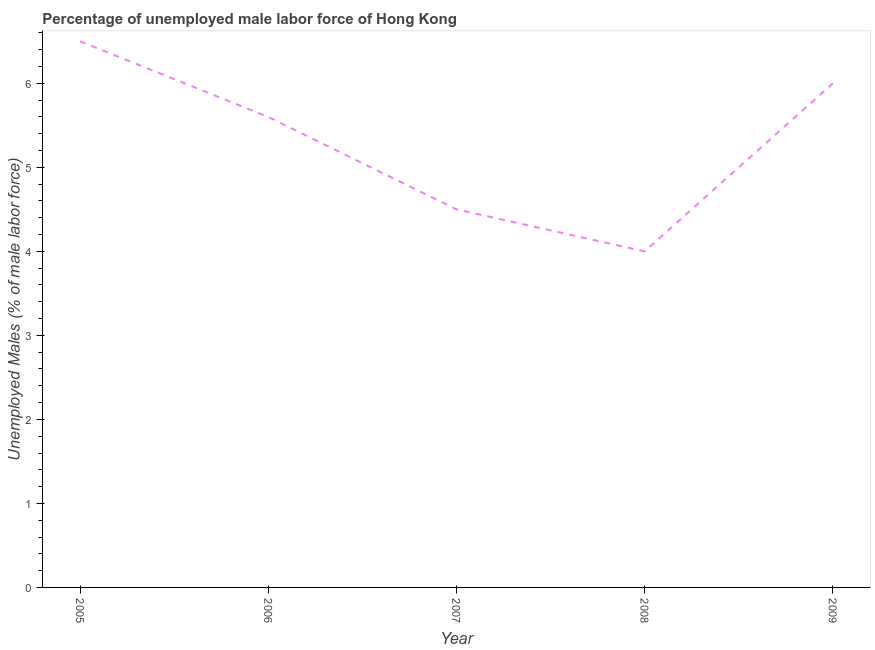What is the total unemployed male labour force in 2006?
Your response must be concise. 5.6. Across all years, what is the maximum total unemployed male labour force?
Keep it short and to the point. 6.5. Across all years, what is the minimum total unemployed male labour force?
Offer a terse response. 4. In which year was the total unemployed male labour force minimum?
Make the answer very short. 2008. What is the sum of the total unemployed male labour force?
Keep it short and to the point. 26.6. What is the difference between the total unemployed male labour force in 2006 and 2007?
Provide a short and direct response. 1.1. What is the average total unemployed male labour force per year?
Your answer should be compact. 5.32. What is the median total unemployed male labour force?
Your response must be concise. 5.6. In how many years, is the total unemployed male labour force greater than 0.4 %?
Provide a succinct answer. 5. Do a majority of the years between 2009 and 2007 (inclusive) have total unemployed male labour force greater than 4.8 %?
Provide a succinct answer. No. What is the ratio of the total unemployed male labour force in 2007 to that in 2008?
Provide a succinct answer. 1.12. Is the total unemployed male labour force in 2006 less than that in 2007?
Give a very brief answer. No. Is the difference between the total unemployed male labour force in 2006 and 2007 greater than the difference between any two years?
Your answer should be very brief. No. In how many years, is the total unemployed male labour force greater than the average total unemployed male labour force taken over all years?
Offer a terse response. 3. How many lines are there?
Make the answer very short. 1. What is the difference between two consecutive major ticks on the Y-axis?
Keep it short and to the point. 1. Are the values on the major ticks of Y-axis written in scientific E-notation?
Your answer should be very brief. No. Does the graph contain any zero values?
Keep it short and to the point. No. What is the title of the graph?
Your answer should be very brief. Percentage of unemployed male labor force of Hong Kong. What is the label or title of the X-axis?
Ensure brevity in your answer.  Year. What is the label or title of the Y-axis?
Your answer should be very brief. Unemployed Males (% of male labor force). What is the Unemployed Males (% of male labor force) in 2005?
Make the answer very short. 6.5. What is the Unemployed Males (% of male labor force) of 2006?
Your response must be concise. 5.6. What is the Unemployed Males (% of male labor force) in 2007?
Keep it short and to the point. 4.5. What is the difference between the Unemployed Males (% of male labor force) in 2005 and 2006?
Provide a succinct answer. 0.9. What is the difference between the Unemployed Males (% of male labor force) in 2005 and 2007?
Your answer should be very brief. 2. What is the difference between the Unemployed Males (% of male labor force) in 2005 and 2009?
Your response must be concise. 0.5. What is the difference between the Unemployed Males (% of male labor force) in 2007 and 2008?
Keep it short and to the point. 0.5. What is the ratio of the Unemployed Males (% of male labor force) in 2005 to that in 2006?
Give a very brief answer. 1.16. What is the ratio of the Unemployed Males (% of male labor force) in 2005 to that in 2007?
Provide a succinct answer. 1.44. What is the ratio of the Unemployed Males (% of male labor force) in 2005 to that in 2008?
Make the answer very short. 1.62. What is the ratio of the Unemployed Males (% of male labor force) in 2005 to that in 2009?
Keep it short and to the point. 1.08. What is the ratio of the Unemployed Males (% of male labor force) in 2006 to that in 2007?
Make the answer very short. 1.24. What is the ratio of the Unemployed Males (% of male labor force) in 2006 to that in 2008?
Offer a very short reply. 1.4. What is the ratio of the Unemployed Males (% of male labor force) in 2006 to that in 2009?
Your answer should be very brief. 0.93. What is the ratio of the Unemployed Males (% of male labor force) in 2008 to that in 2009?
Make the answer very short. 0.67. 